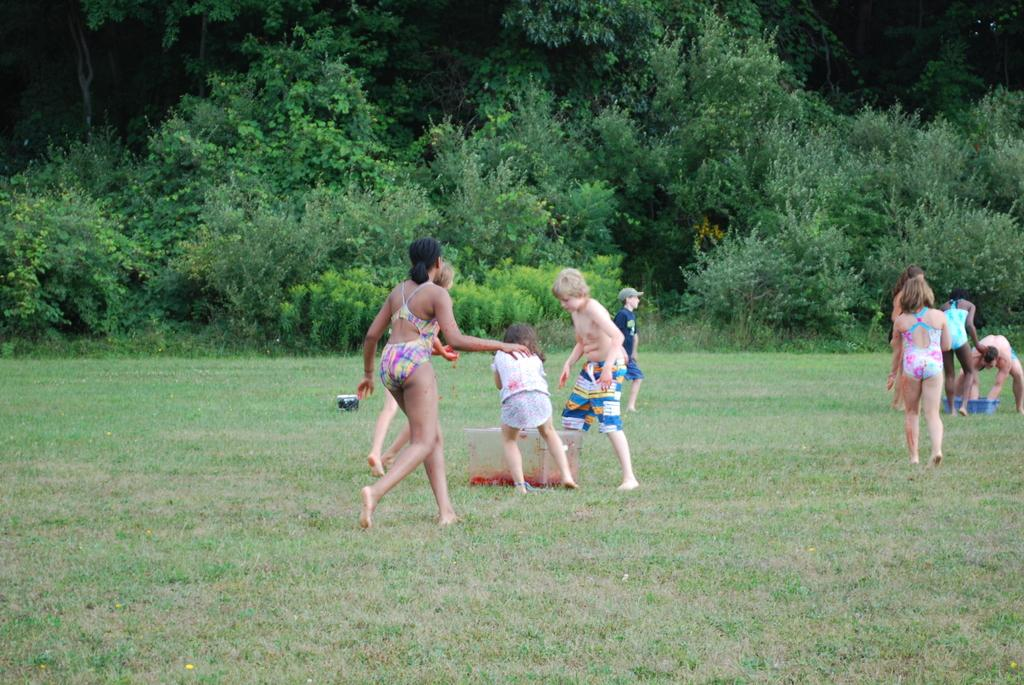What is happening on the ground in the image? There are people on the ground in the image. What objects can be seen besides the people? There are boxes in the image. What can be seen in the distance in the image? There are trees in the background of the image. What is visible at the bottom of the image? The ground is visible at the bottom of the image. What type of gold rod can be seen in the image? There is no gold rod present in the image. How does the taste of the people on the ground compare in the image? There is no information about the taste of the people in the image, as it is a visual medium. 